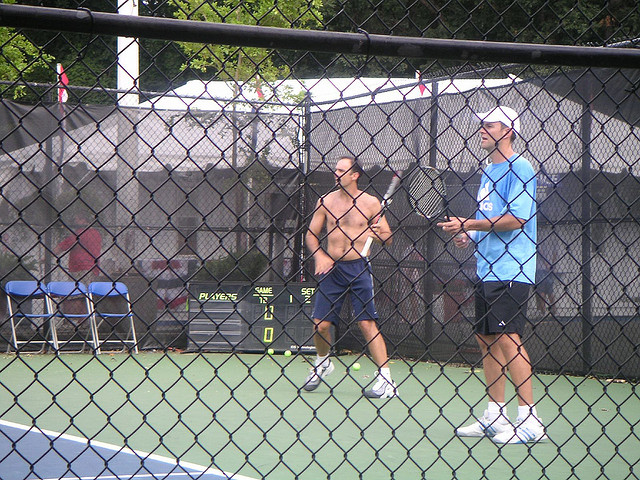How many men are wearing hats? There is 1 man wearing a hat in the image. He is on the right side, sporting a white cap, which contrasts with his blue shirt. 